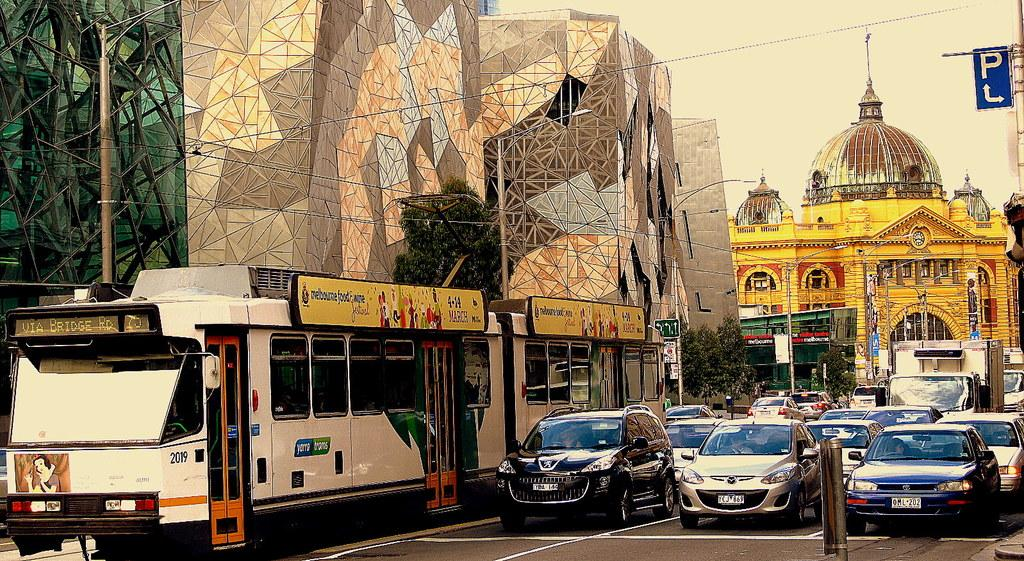Provide a one-sentence caption for the provided image. many cars and a sign with the letter P above the street. 